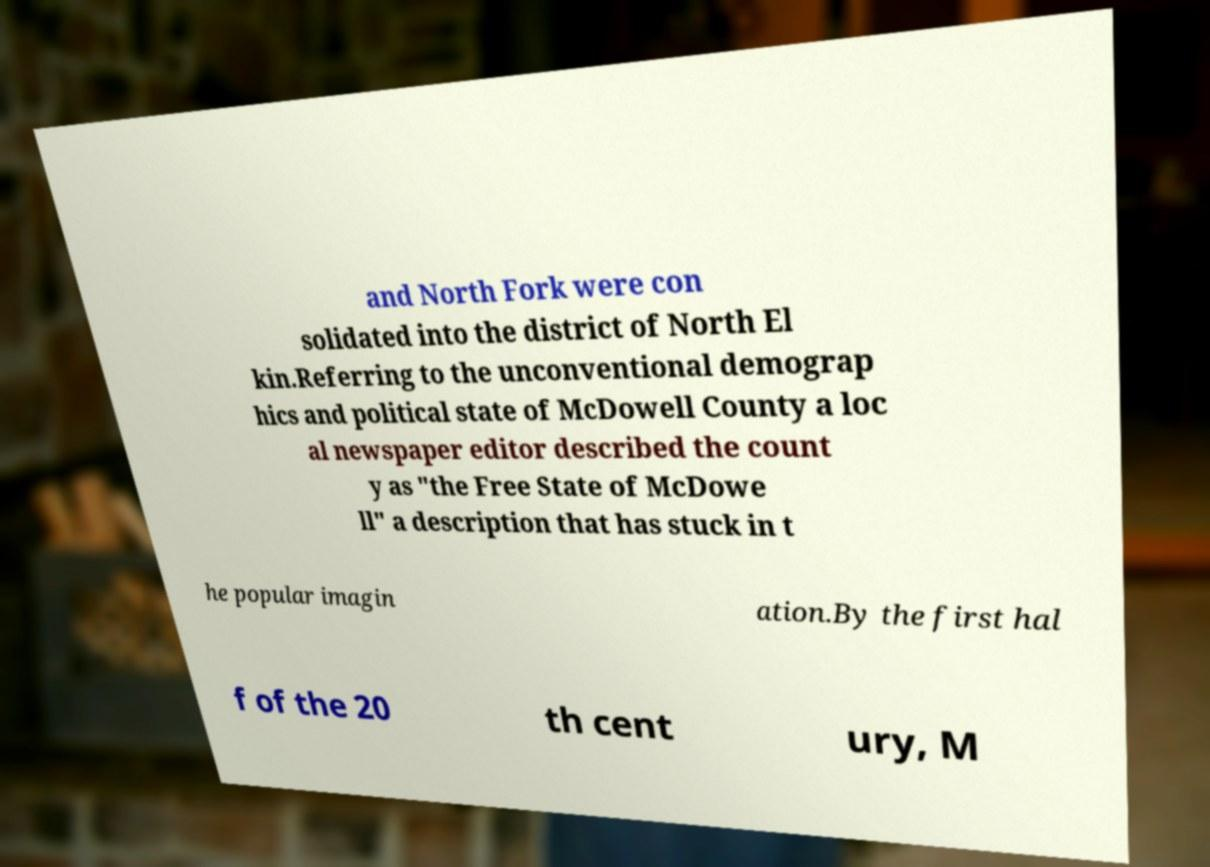What messages or text are displayed in this image? I need them in a readable, typed format. and North Fork were con solidated into the district of North El kin.Referring to the unconventional demograp hics and political state of McDowell County a loc al newspaper editor described the count y as "the Free State of McDowe ll" a description that has stuck in t he popular imagin ation.By the first hal f of the 20 th cent ury, M 